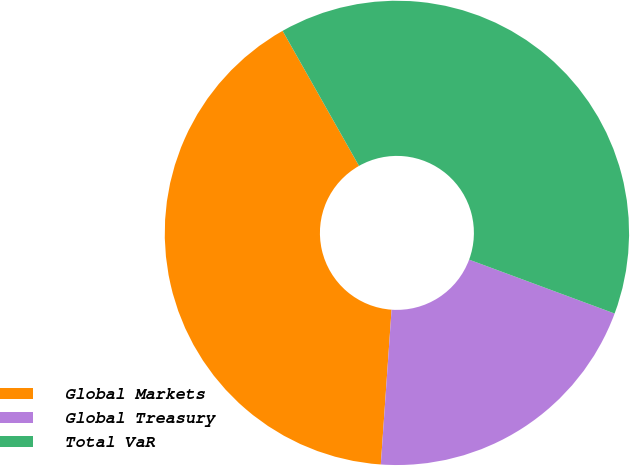<chart> <loc_0><loc_0><loc_500><loc_500><pie_chart><fcel>Global Markets<fcel>Global Treasury<fcel>Total VaR<nl><fcel>40.7%<fcel>20.46%<fcel>38.84%<nl></chart> 